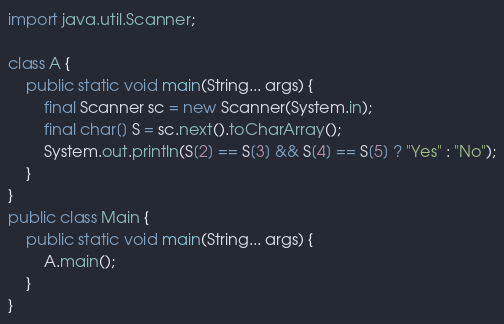Convert code to text. <code><loc_0><loc_0><loc_500><loc_500><_Java_>import java.util.Scanner;

class A {
    public static void main(String... args) {
        final Scanner sc = new Scanner(System.in);
        final char[] S = sc.next().toCharArray();
        System.out.println(S[2] == S[3] && S[4] == S[5] ? "Yes" : "No");
    }
}
public class Main {
    public static void main(String... args) {
        A.main();
    }
}
</code> 